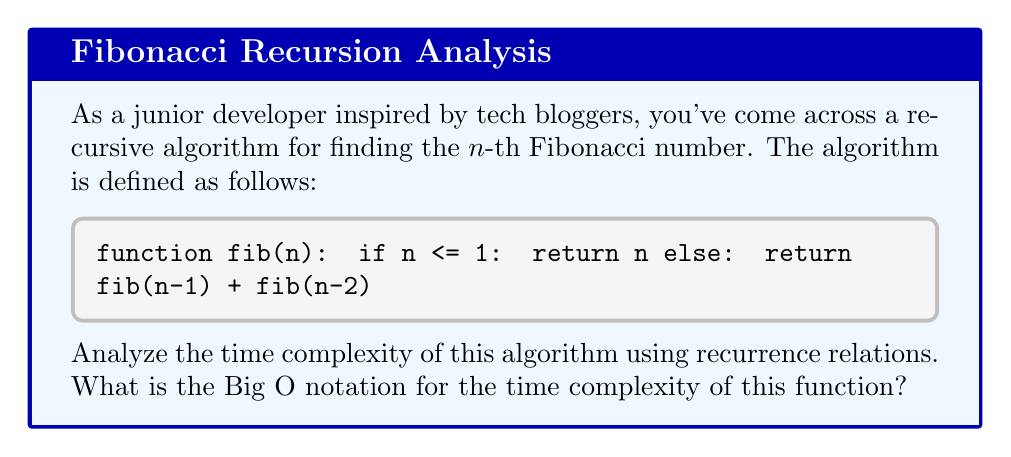Show me your answer to this math problem. Let's analyze the time complexity step by step:

1) First, we need to define the recurrence relation for the number of operations T(n) performed by the function:

   $$T(n) = T(n-1) + T(n-2) + c$$

   where c is a constant representing the time for the addition and comparison operations.

2) This recurrence relation is similar to the Fibonacci sequence itself, which grows exponentially.

3) We can prove by induction that T(n) ≥ Fib(n), where Fib(n) is the n-th Fibonacci number:

   Base cases: 
   T(0) ≥ Fib(0) = 0
   T(1) ≥ Fib(1) = 1

   Inductive step:
   Assume T(k) ≥ Fib(k) for all k < n
   Then, T(n) = T(n-1) + T(n-2) + c ≥ Fib(n-1) + Fib(n-2) + c > Fib(n)

4) We know that the Fibonacci sequence grows exponentially. Specifically:

   $$Fib(n) \approx \frac{\phi^n}{\sqrt{5}}$$

   where φ ≈ 1.618 is the golden ratio.

5) Therefore, T(n) grows at least as fast as $\phi^n$.

6) In Big O notation, we express this as O($\phi^n$) or more commonly as O($2^n$), since $\phi^n$ and $2^n$ are of the same order of magnitude for exponential functions.
Answer: O($2^n$) 